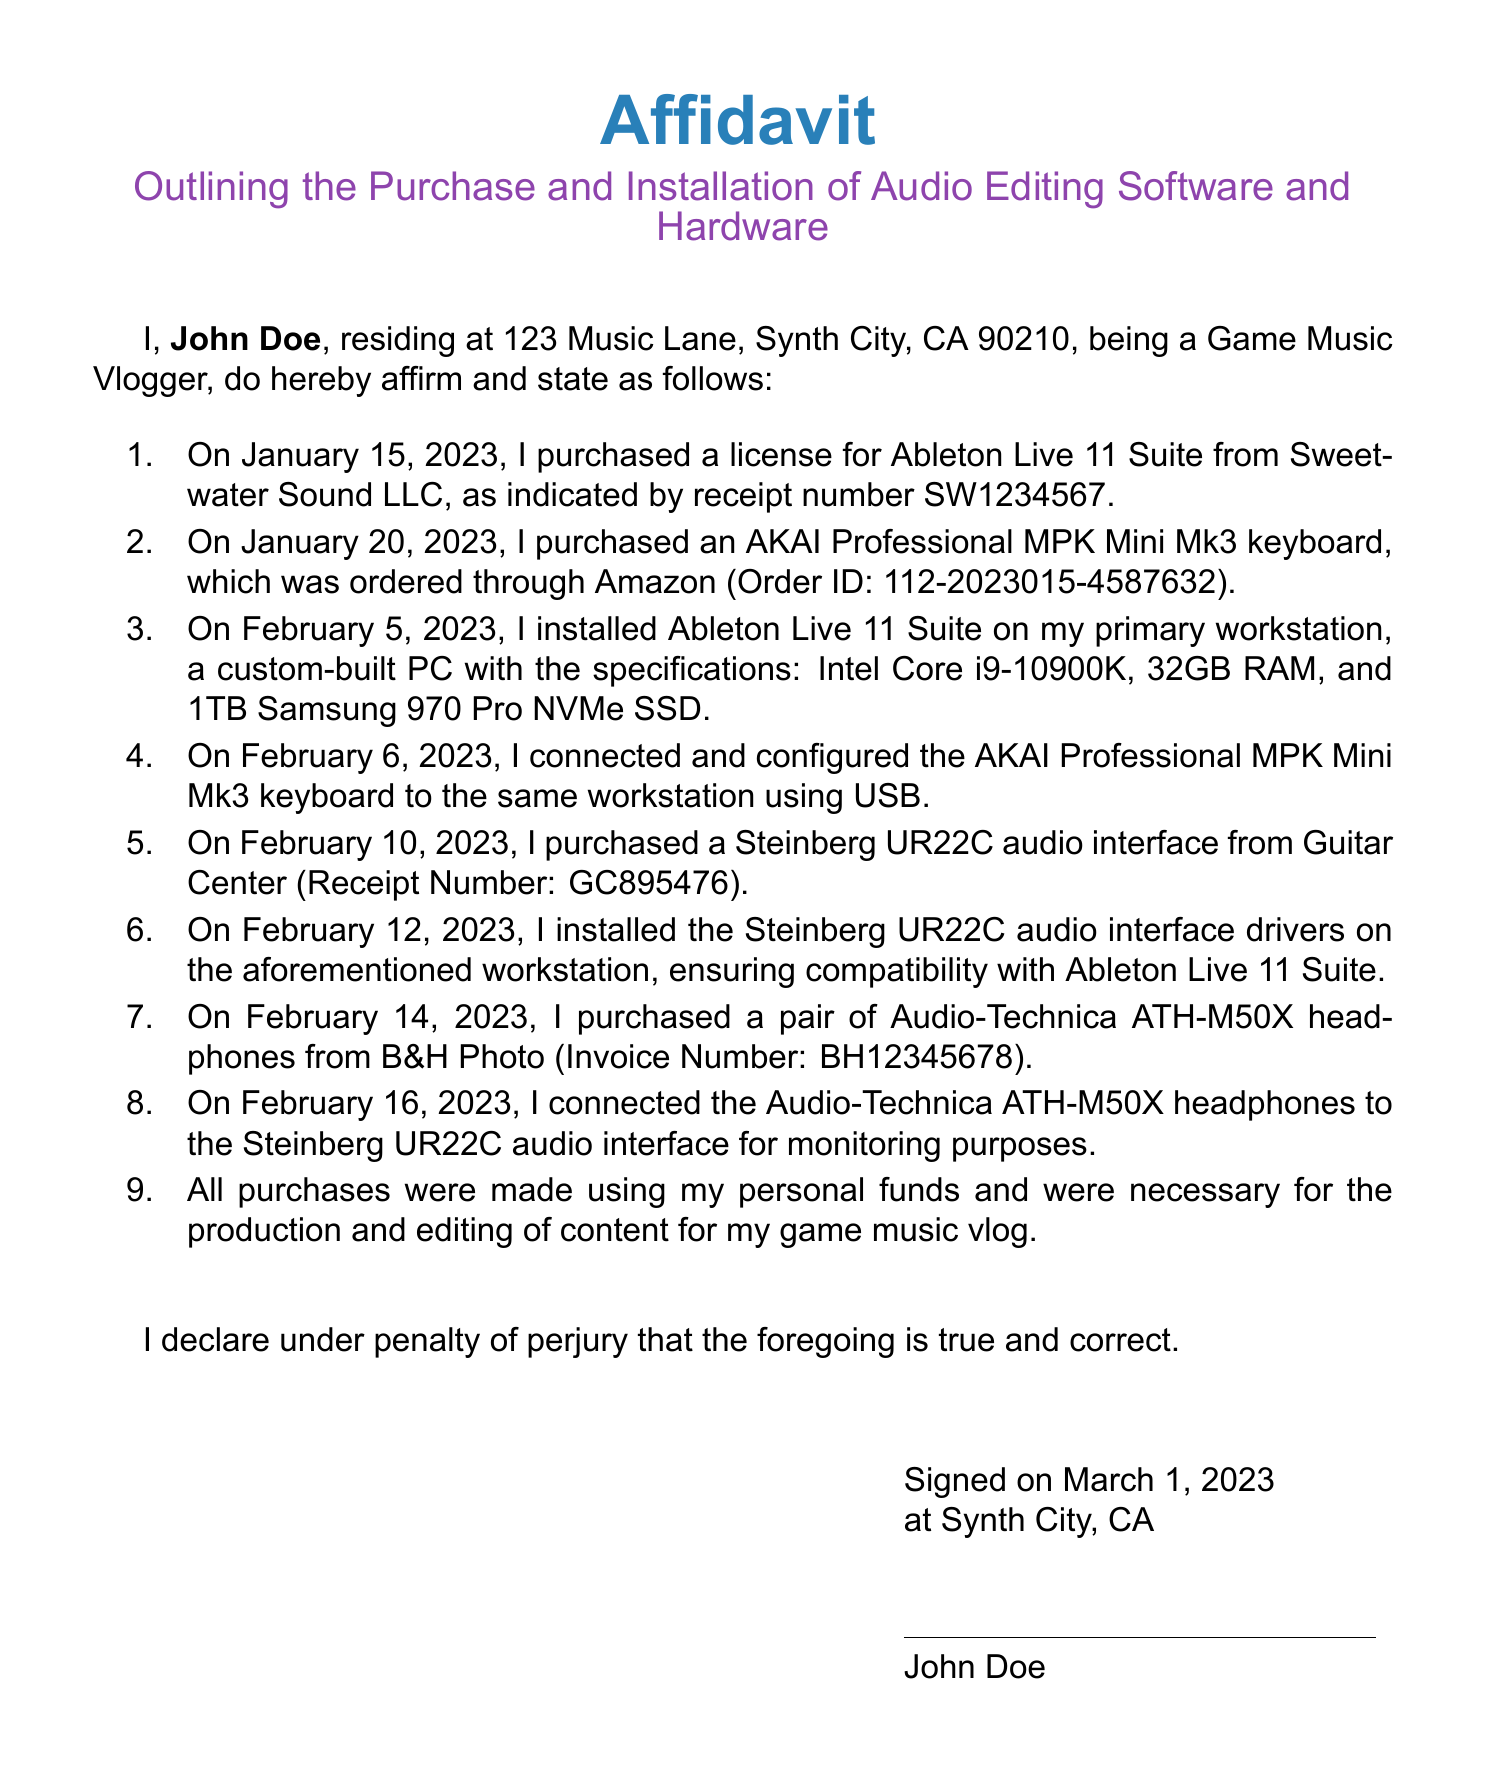What is the date of the first purchase? The date of the first purchase documented is January 15, 2023.
Answer: January 15, 2023 What software was purchased? The document states that a license for Ableton Live 11 Suite was purchased.
Answer: Ableton Live 11 Suite What is the order ID for the AKAI keyboard? The order ID for the AKAI keyboard purchase is explicitly stated in the document as 112-2023015-4587632.
Answer: 112-2023015-4587632 On what date was the Steinberg audio interface installed? The Steinberg audio interface drivers were installed on February 12, 2023.
Answer: February 12, 2023 How many items were purchased in total? The document lists a total of 4 items purchased, including software and hardware.
Answer: 4 What is the purpose of the purchases made? The stated purpose of the purchases is for the production and editing of content for the game music vlog.
Answer: Production and editing of content Who signed the affidavit? The affidavit was signed by John Doe.
Answer: John Doe What is the location stated in the affidavit? The affidavit mentions the location as Synth City, CA.
Answer: Synth City, CA What color is used for the title? The title of the affidavit is in synth blue color.
Answer: Synth blue 